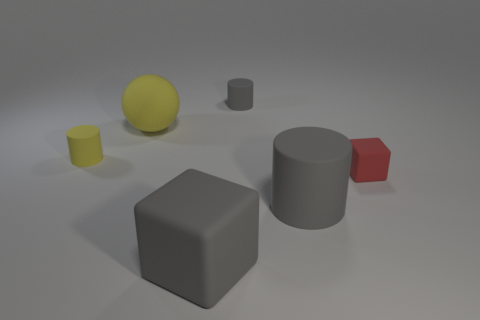Subtract all green blocks. How many gray cylinders are left? 2 Add 3 big gray objects. How many objects exist? 9 Subtract all spheres. How many objects are left? 5 Add 4 big matte cylinders. How many big matte cylinders exist? 5 Subtract 0 purple blocks. How many objects are left? 6 Subtract all big rubber blocks. Subtract all metal spheres. How many objects are left? 5 Add 5 yellow rubber cylinders. How many yellow rubber cylinders are left? 6 